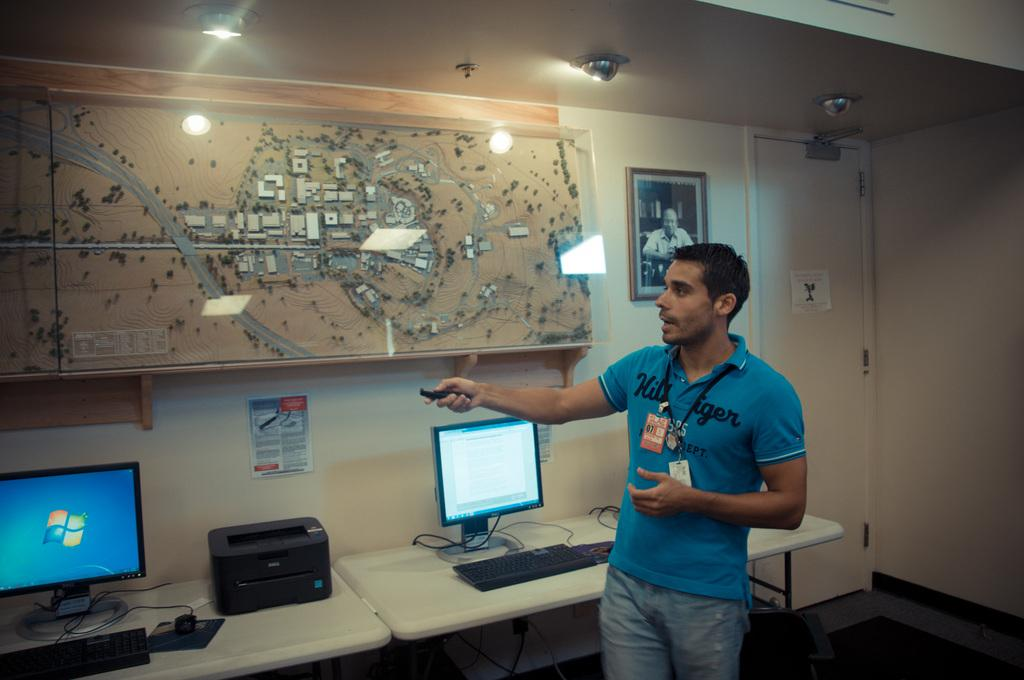<image>
Provide a brief description of the given image. A man wearing a teal HIlfiger shirt if presenting something. 